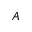<formula> <loc_0><loc_0><loc_500><loc_500>A</formula> 